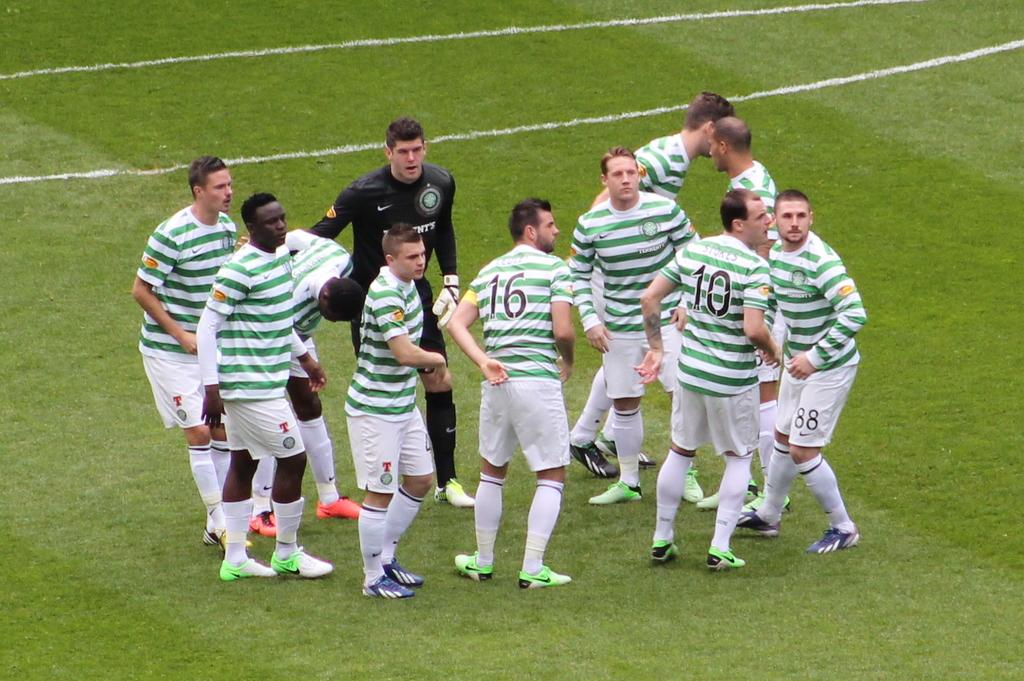<image>
Render a clear and concise summary of the photo. Ten men in green and white, striped, team jerseys with numbers 10 and 16 clearly visible, and standing on a green field, gathered around a man in a black shirt. 